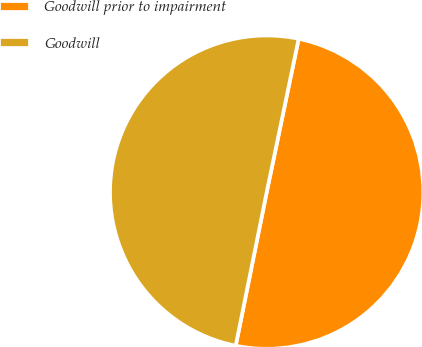Convert chart. <chart><loc_0><loc_0><loc_500><loc_500><pie_chart><fcel>Goodwill prior to impairment<fcel>Goodwill<nl><fcel>49.9%<fcel>50.1%<nl></chart> 